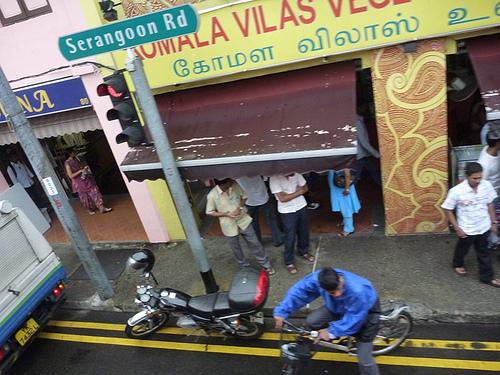<image>
Is there a bicycle on the man? No. The bicycle is not positioned on the man. They may be near each other, but the bicycle is not supported by or resting on top of the man. 